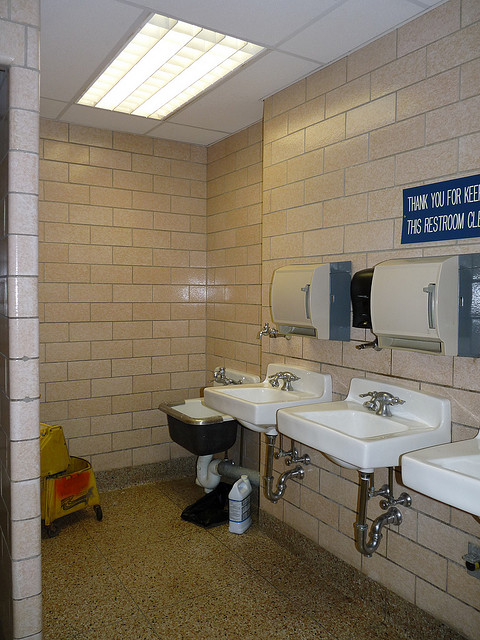Is this a public restroom? Yes, this is a public restroom designed to accommodate multiple users, equipped with several sinks and a robust, utilitarian setup. 